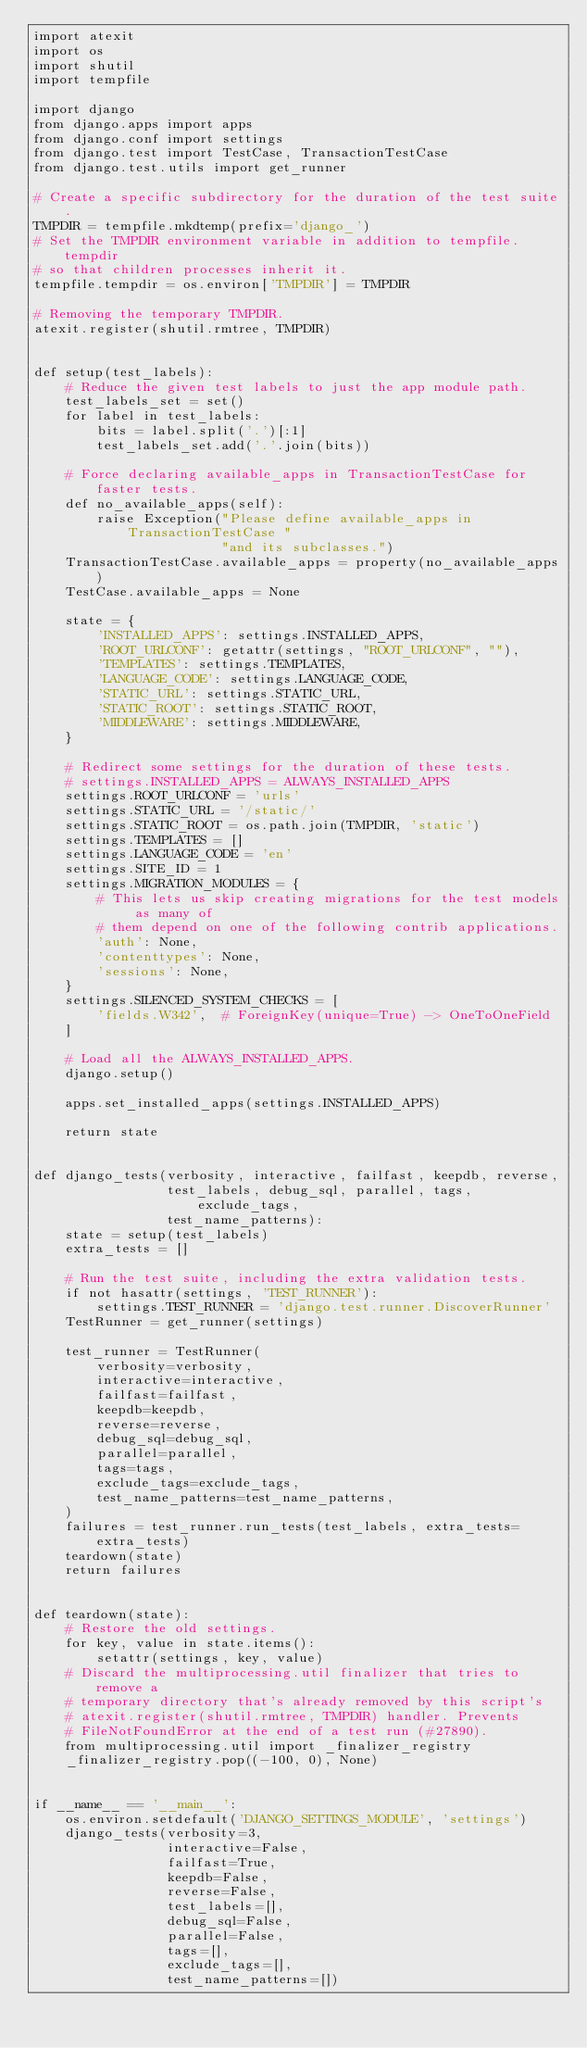Convert code to text. <code><loc_0><loc_0><loc_500><loc_500><_Python_>import atexit
import os
import shutil
import tempfile

import django
from django.apps import apps
from django.conf import settings
from django.test import TestCase, TransactionTestCase
from django.test.utils import get_runner

# Create a specific subdirectory for the duration of the test suite.
TMPDIR = tempfile.mkdtemp(prefix='django_')
# Set the TMPDIR environment variable in addition to tempfile.tempdir
# so that children processes inherit it.
tempfile.tempdir = os.environ['TMPDIR'] = TMPDIR

# Removing the temporary TMPDIR.
atexit.register(shutil.rmtree, TMPDIR)


def setup(test_labels):
    # Reduce the given test labels to just the app module path.
    test_labels_set = set()
    for label in test_labels:
        bits = label.split('.')[:1]
        test_labels_set.add('.'.join(bits))

    # Force declaring available_apps in TransactionTestCase for faster tests.
    def no_available_apps(self):
        raise Exception("Please define available_apps in TransactionTestCase "
                        "and its subclasses.")
    TransactionTestCase.available_apps = property(no_available_apps)
    TestCase.available_apps = None

    state = {
        'INSTALLED_APPS': settings.INSTALLED_APPS,
        'ROOT_URLCONF': getattr(settings, "ROOT_URLCONF", ""),
        'TEMPLATES': settings.TEMPLATES,
        'LANGUAGE_CODE': settings.LANGUAGE_CODE,
        'STATIC_URL': settings.STATIC_URL,
        'STATIC_ROOT': settings.STATIC_ROOT,
        'MIDDLEWARE': settings.MIDDLEWARE,
    }

    # Redirect some settings for the duration of these tests.
    # settings.INSTALLED_APPS = ALWAYS_INSTALLED_APPS
    settings.ROOT_URLCONF = 'urls'
    settings.STATIC_URL = '/static/'
    settings.STATIC_ROOT = os.path.join(TMPDIR, 'static')
    settings.TEMPLATES = []
    settings.LANGUAGE_CODE = 'en'
    settings.SITE_ID = 1
    settings.MIGRATION_MODULES = {
        # This lets us skip creating migrations for the test models as many of
        # them depend on one of the following contrib applications.
        'auth': None,
        'contenttypes': None,
        'sessions': None,
    }
    settings.SILENCED_SYSTEM_CHECKS = [
        'fields.W342',  # ForeignKey(unique=True) -> OneToOneField
    ]

    # Load all the ALWAYS_INSTALLED_APPS.
    django.setup()

    apps.set_installed_apps(settings.INSTALLED_APPS)

    return state


def django_tests(verbosity, interactive, failfast, keepdb, reverse,
                 test_labels, debug_sql, parallel, tags, exclude_tags,
                 test_name_patterns):
    state = setup(test_labels)
    extra_tests = []

    # Run the test suite, including the extra validation tests.
    if not hasattr(settings, 'TEST_RUNNER'):
        settings.TEST_RUNNER = 'django.test.runner.DiscoverRunner'
    TestRunner = get_runner(settings)

    test_runner = TestRunner(
        verbosity=verbosity,
        interactive=interactive,
        failfast=failfast,
        keepdb=keepdb,
        reverse=reverse,
        debug_sql=debug_sql,
        parallel=parallel,
        tags=tags,
        exclude_tags=exclude_tags,
        test_name_patterns=test_name_patterns,
    )
    failures = test_runner.run_tests(test_labels, extra_tests=extra_tests)
    teardown(state)
    return failures


def teardown(state):
    # Restore the old settings.
    for key, value in state.items():
        setattr(settings, key, value)
    # Discard the multiprocessing.util finalizer that tries to remove a
    # temporary directory that's already removed by this script's
    # atexit.register(shutil.rmtree, TMPDIR) handler. Prevents
    # FileNotFoundError at the end of a test run (#27890).
    from multiprocessing.util import _finalizer_registry
    _finalizer_registry.pop((-100, 0), None)


if __name__ == '__main__':
    os.environ.setdefault('DJANGO_SETTINGS_MODULE', 'settings')
    django_tests(verbosity=3,
                 interactive=False,
                 failfast=True,
                 keepdb=False,
                 reverse=False,
                 test_labels=[],
                 debug_sql=False,
                 parallel=False,
                 tags=[],
                 exclude_tags=[],
                 test_name_patterns=[])
</code> 